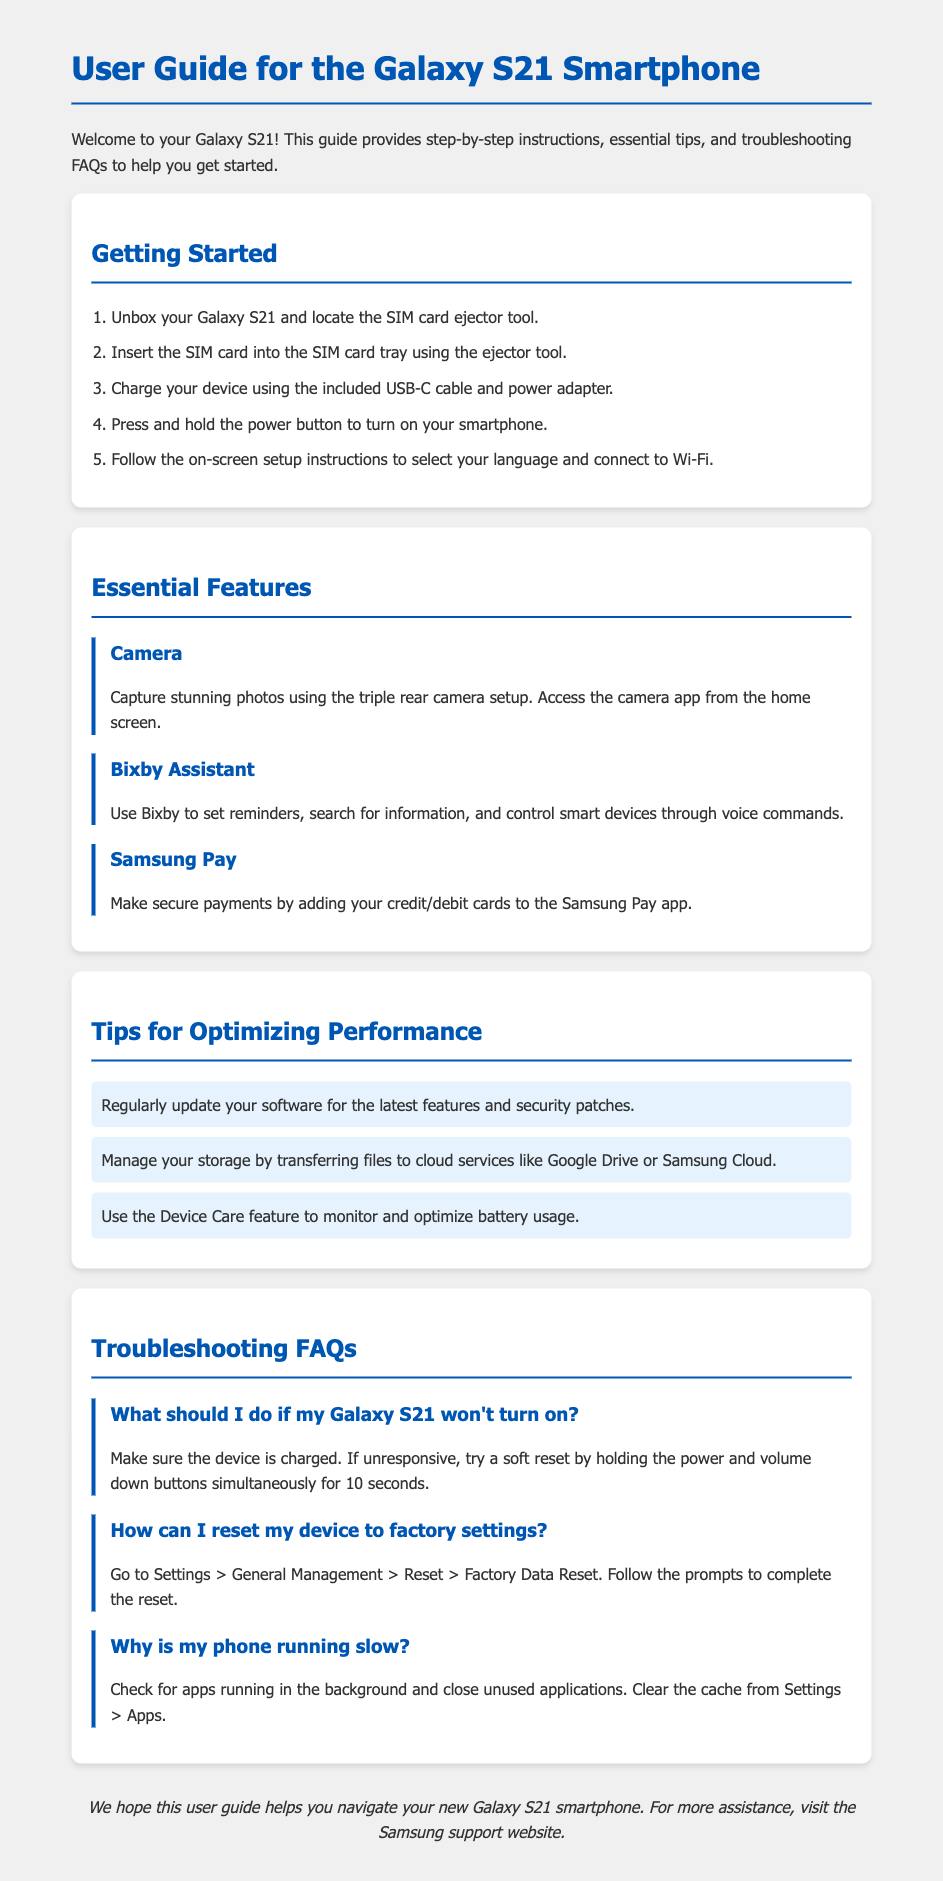What is the first step in getting started? The first step is to unbox your Galaxy S21 and locate the SIM card ejector tool.
Answer: Unbox your Galaxy S21 and locate the SIM card ejector tool What is the primary function of Bixby Assistant? Bixby Assistant is used to set reminders, search for information, and control smart devices through voice commands.
Answer: Set reminders, search for information, and control smart devices How many rear cameras does the Galaxy S21 have? The document specifies that the Galaxy S21 features a triple rear camera setup.
Answer: Triple rear camera setup What should you do if the Galaxy S21 won't turn on? The suggested action is to make sure the device is charged and perform a soft reset if unresponsive.
Answer: Make sure the device is charged; try a soft reset Where can you find the option to reset your device to factory settings? The path to reset the device is listed in the document as Settings > General Management > Reset > Factory Data Reset.
Answer: Settings > General Management > Reset > Factory Data Reset How many tips are provided for optimizing performance? The document lists three tips for optimizing performance.
Answer: Three tips What feature should be used to monitor battery usage? The document recommends using the Device Care feature for monitoring battery usage.
Answer: Device Care feature What is a troubleshooting step for when the phone is running slow? The document suggests checking for apps running in the background and closing unused applications.
Answer: Check for apps running in the background and close unused applications What color is used for headings in the document? The document designates blue (#0056b3) for the headings, which is consistent throughout.
Answer: Blue (#0056b3) 